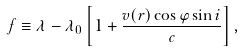Convert formula to latex. <formula><loc_0><loc_0><loc_500><loc_500>f \equiv \lambda - \lambda _ { 0 } \left [ 1 + \frac { v ( r ) \cos \varphi \sin i } { c } \right ] ,</formula> 